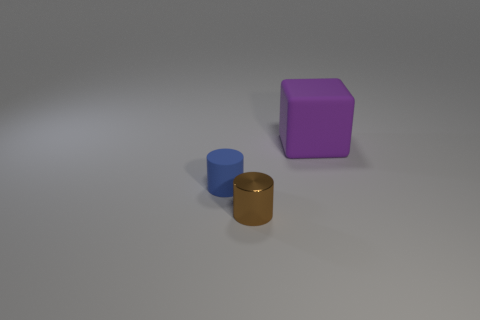What materials do the objects in the image appear to be made from? The objects in the image appear to have different textures. The purple object seems to have a matte surface possibly indicating a rubber-like material, the golden brown cylinder has a shiny surface suggesting it might be metallic, and the blue object also has a matte finish which could indicate it's made from a similar material to the purple object. 